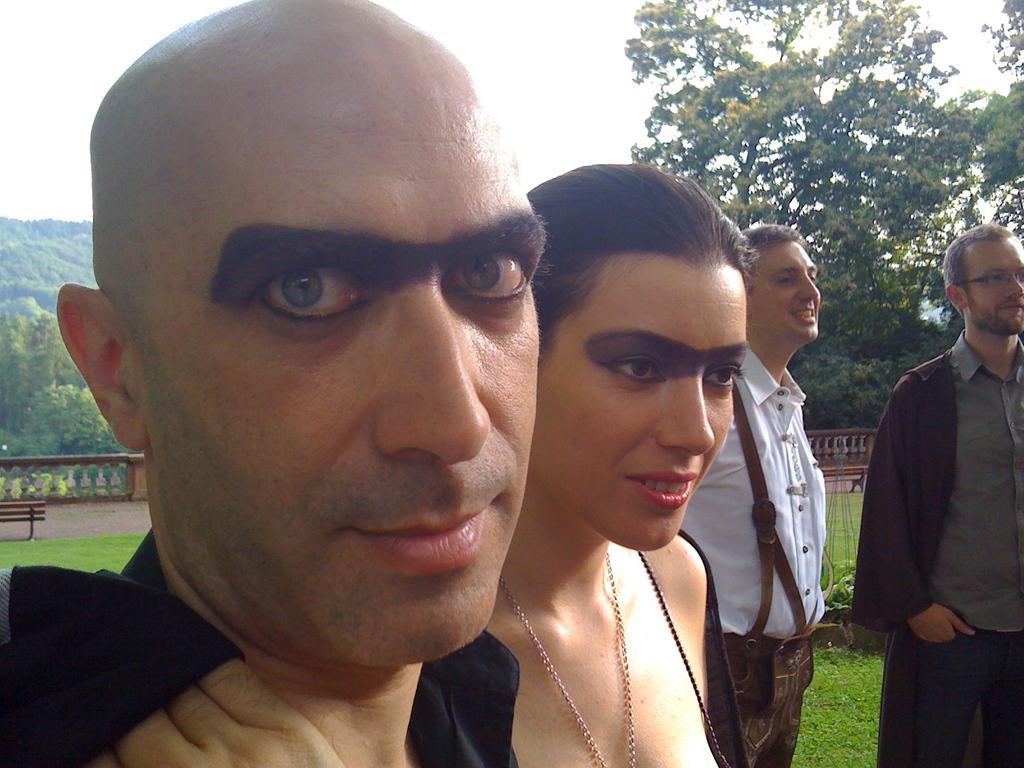Please provide a concise description of this image. In this image I can see few persons are standing. In the background I can see the bench, the ground, some grass, the railing, few trees which are green in color and the sky. 